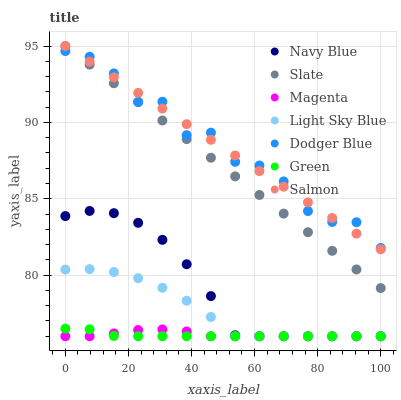Does Green have the minimum area under the curve?
Answer yes or no. Yes. Does Dodger Blue have the maximum area under the curve?
Answer yes or no. Yes. Does Slate have the minimum area under the curve?
Answer yes or no. No. Does Slate have the maximum area under the curve?
Answer yes or no. No. Is Salmon the smoothest?
Answer yes or no. Yes. Is Dodger Blue the roughest?
Answer yes or no. Yes. Is Slate the smoothest?
Answer yes or no. No. Is Slate the roughest?
Answer yes or no. No. Does Navy Blue have the lowest value?
Answer yes or no. Yes. Does Slate have the lowest value?
Answer yes or no. No. Does Salmon have the highest value?
Answer yes or no. Yes. Does Light Sky Blue have the highest value?
Answer yes or no. No. Is Magenta less than Dodger Blue?
Answer yes or no. Yes. Is Dodger Blue greater than Light Sky Blue?
Answer yes or no. Yes. Does Dodger Blue intersect Salmon?
Answer yes or no. Yes. Is Dodger Blue less than Salmon?
Answer yes or no. No. Is Dodger Blue greater than Salmon?
Answer yes or no. No. Does Magenta intersect Dodger Blue?
Answer yes or no. No. 